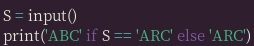Convert code to text. <code><loc_0><loc_0><loc_500><loc_500><_Python_>S = input()
print('ABC' if S == 'ARC' else 'ARC')</code> 